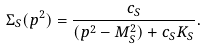<formula> <loc_0><loc_0><loc_500><loc_500>\Sigma _ { S } ( p ^ { 2 } ) = \frac { c _ { S } } { ( p ^ { 2 } - M _ { S } ^ { 2 } ) + c _ { S } K _ { S } } .</formula> 